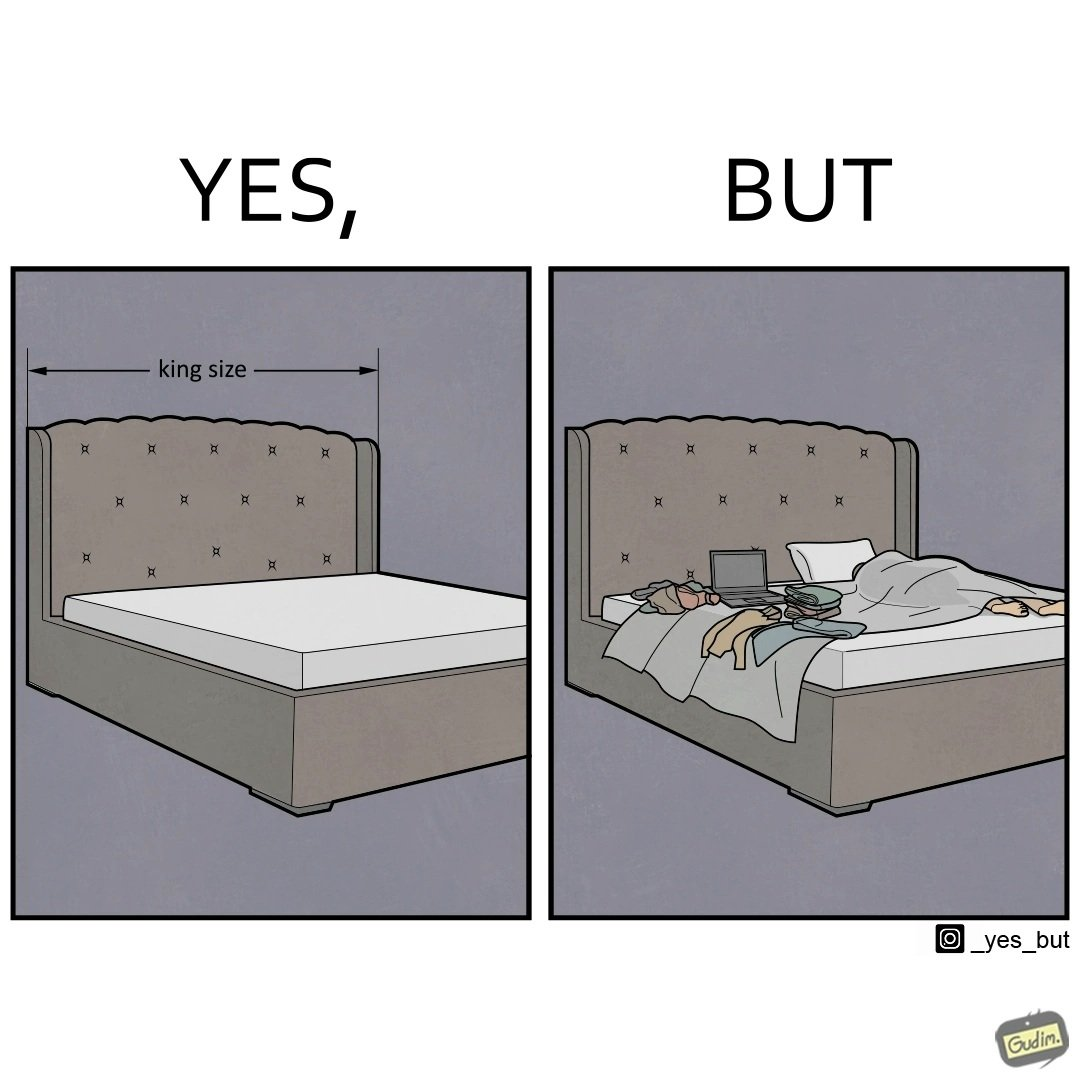Describe what you see in this image. Although the person has purchased a king size bed, but only less than half of the space is used by the person for sleeping. 